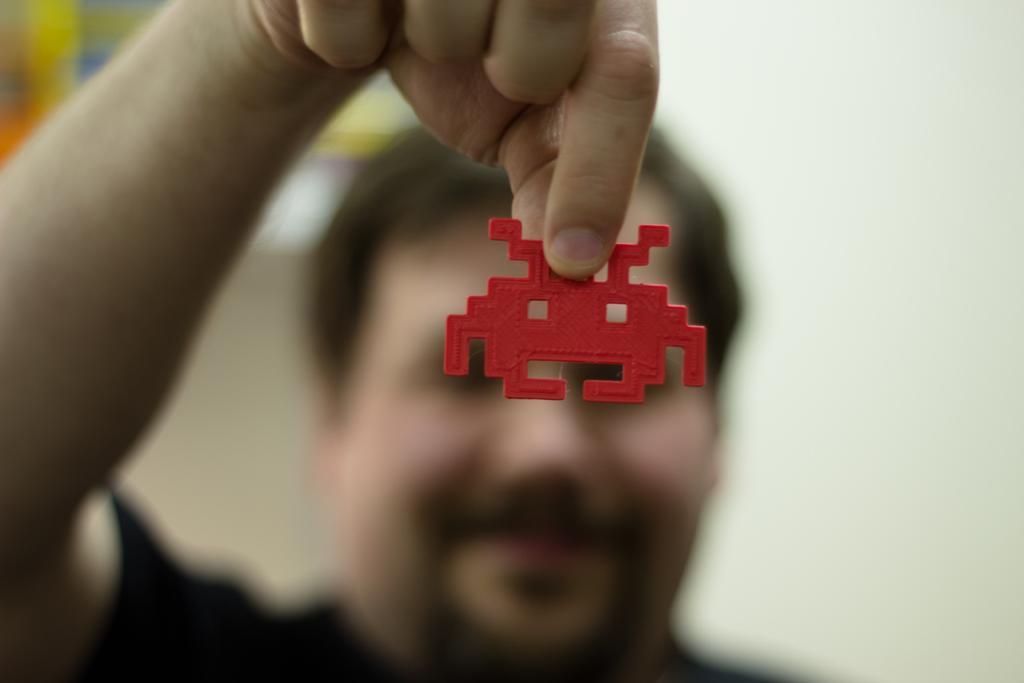How would you summarize this image in a sentence or two? In this image I can see a man is holding a red colour thing. I can also see this image is little bit blurry. 